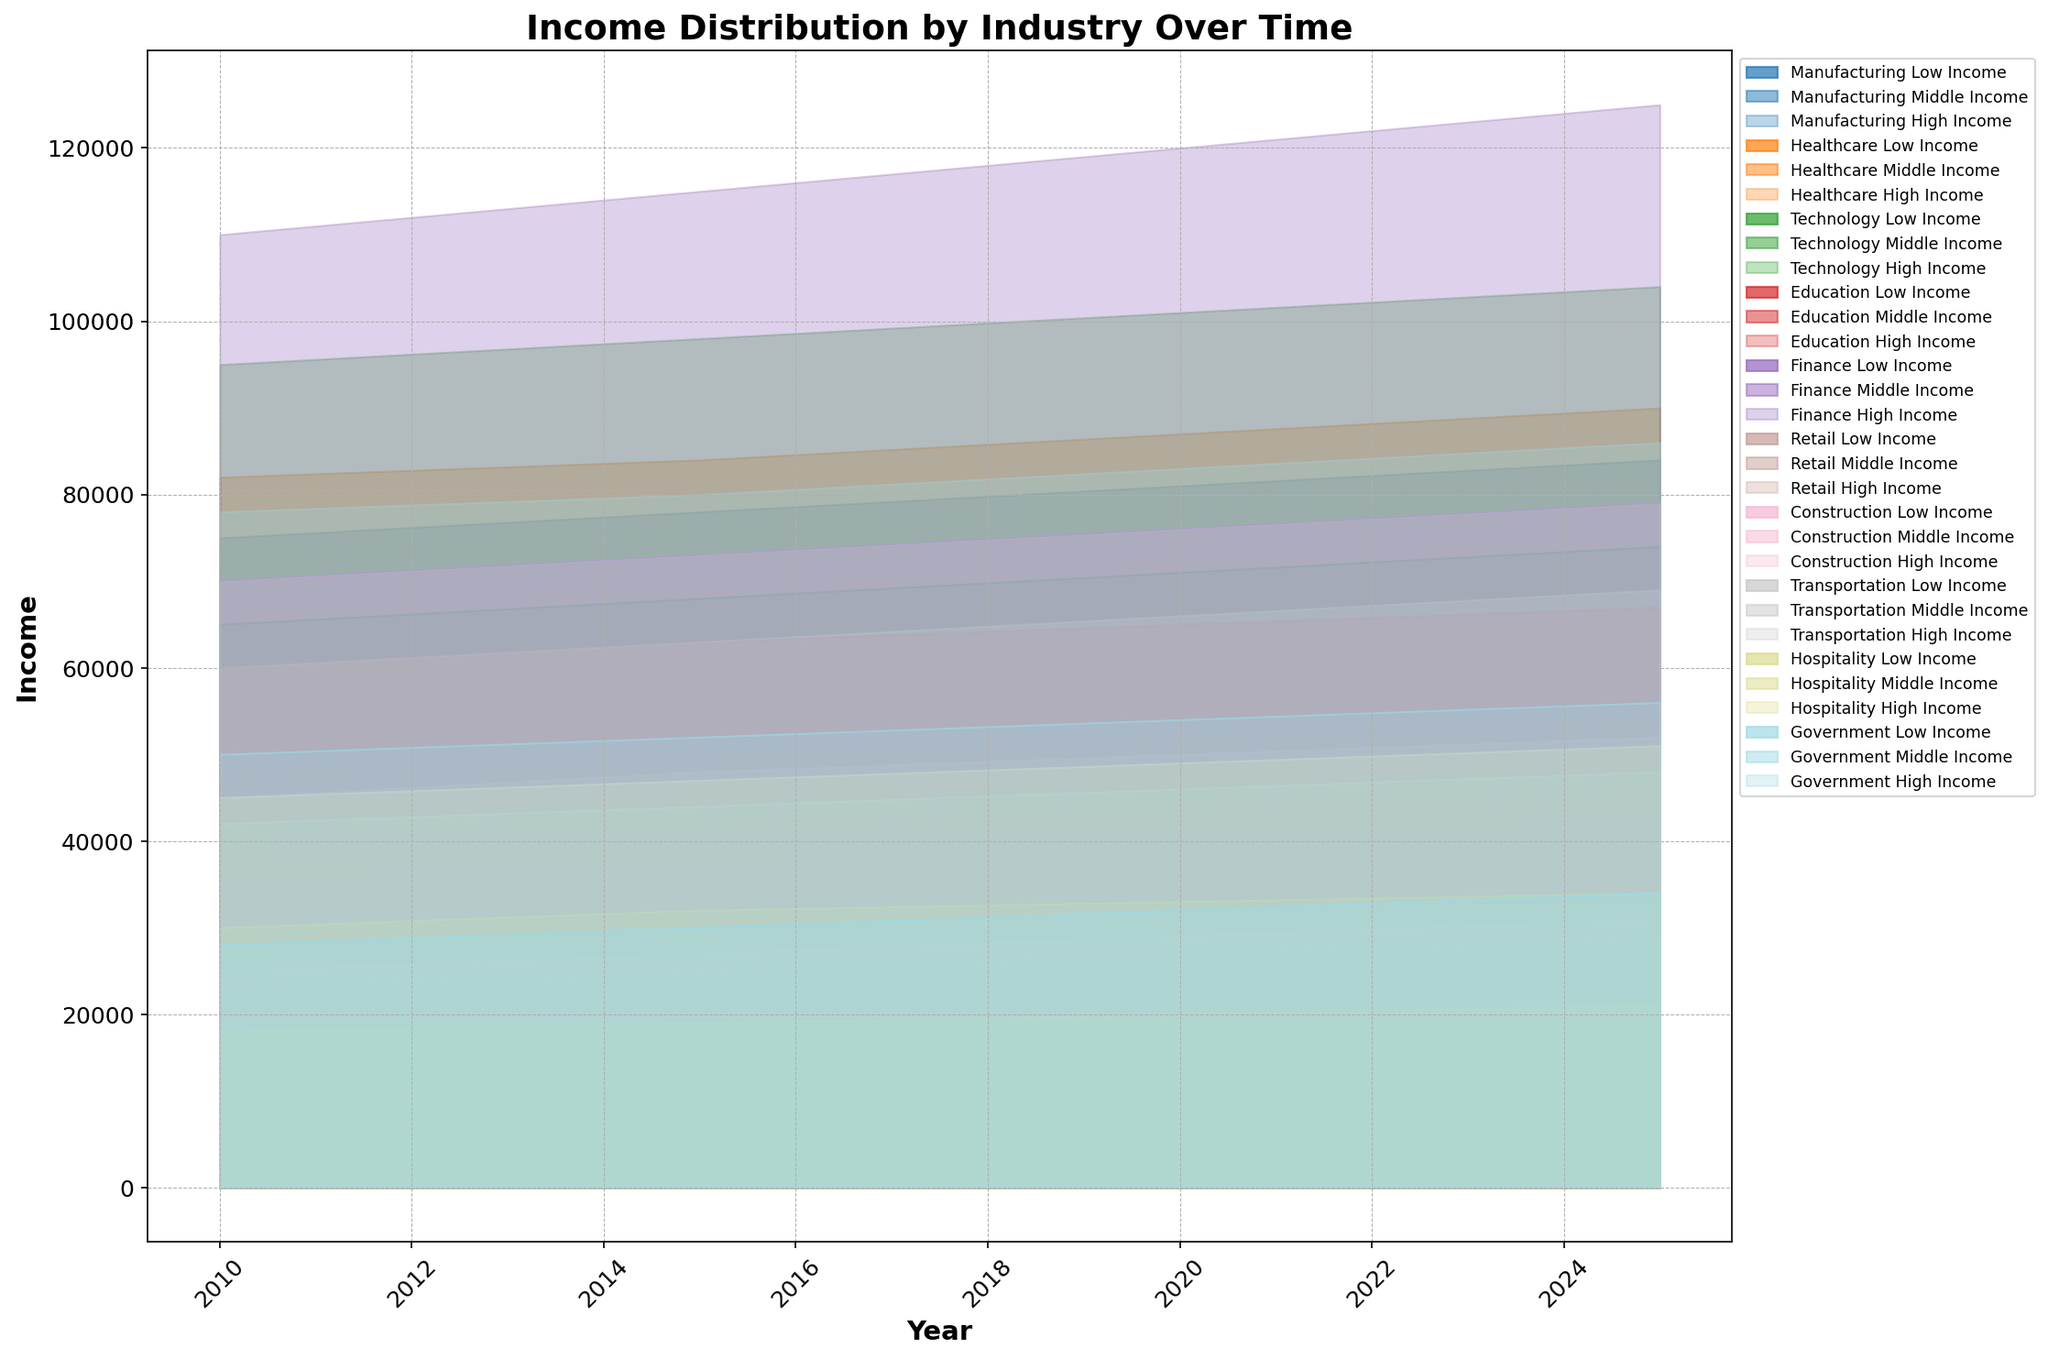What's the trend of high-income wages in the Finance industry from 2010 to 2025? From the figure, observe the high-income bracket for the Finance industry from 2010 to 2025. Note the income values at each year: 2010 (110000), 2015 (115000), 2020 (120000), and 2025 (125000). These values indicate a consistent increase over time.
Answer: Increasing Which industry had the highest middle-income level in 2020? Review the figure, focusing on the middle-income sections for all industries in 2020. Compare the midpoint levels for each industry. The Technology industry has the highest middle-income level at 71000.
Answer: Technology Compare the low-income ranges between Manufacturing and Education industries in 2010. Which one was higher? Analyze the figure for the low-income brackets of Manufacturing and Education in 2010. In 2010, Manufacturing had a low-income value of 25000, while Education had a lower value of 20000.
Answer: Manufacturing In 2025, what is the income gap between the highest and lowest wage brackets in the Technology industry? Locate the Technology industry's top and bottom income brackets in 2025 from the figure. The high-income value is 104000 and the low-income value is 37000. Subtract the lower value from the higher value: 104000 - 37000 = 67000.
Answer: 67000 Which industry exhibits the smallest income disparities (gap between high and low incomes) in 2010? Examine the figure for 2010 for each industry and calculate the income gap (high - low) for each. The Hospitality industry shows the smallest income gap: 45000 - 18000 = 27000.
Answer: Hospitality How did the low-income wage for the Healthcare industry change from 2010 to 2015? Observe the low-income bracket for Healthcare in 2010 (22000) and 2015 (24000). The difference is: 24000 - 22000 = 2000, indicating an increase.
Answer: Increased by 2000 Which sector showed the greatest improvement in high-income wages between 2010 and 2025? For each industry, calculate the difference between high-income wages in 2010 and 2025. The Finance industry shows the greatest improvement from 110000 in 2010 to 125000 in 2025, a difference of 15000.
Answer: Finance Between 2010 and 2025, did any industry see its middle-income level stay constant? For all industries, compare the middle-income values at 2010 and 2025. None of the industries show a constant middle-income level over the years; they all change over time.
Answer: No What is the visual gap between low-income wages in Government and Hospitality sectors in 2020? In the figure, note the low-income values for Government (32000) and Hospitality (20000) in 2020. The visual gap, computed as: 32000 - 20000 = 12000, is clearly observed.
Answer: 12000 Which industry's high-income range saw the least growth from 2010 to 2020? Calculate the difference in high-income values from 2010 to 2020 for each industry. Hospitality went from 45000 to 49000, the smallest growth: 49000 - 45000 = 4000.
Answer: Hospitality 